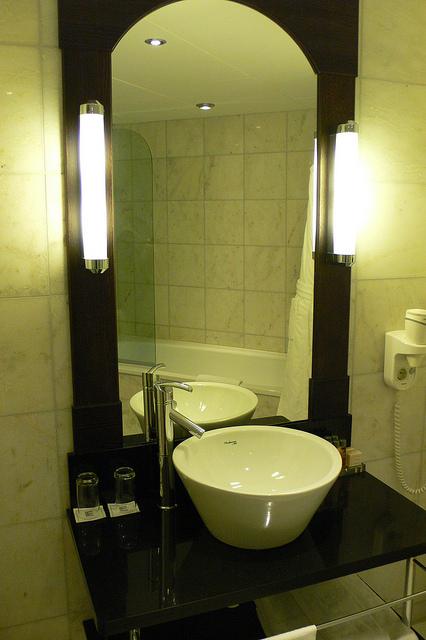Are the lights on?
Short answer required. Yes. What room is this?
Keep it brief. Bathroom. Is the sink big?
Give a very brief answer. Yes. 